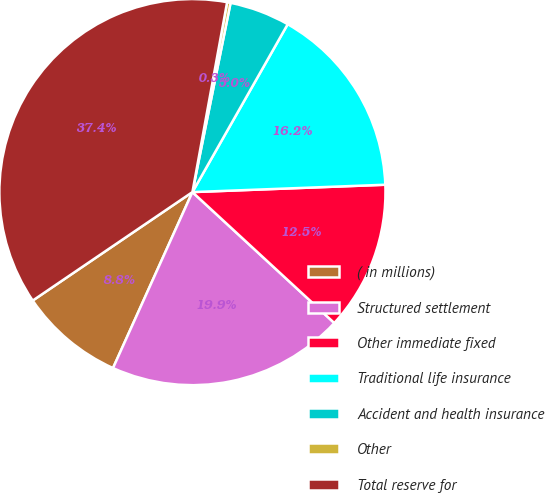<chart> <loc_0><loc_0><loc_500><loc_500><pie_chart><fcel>( in millions)<fcel>Structured settlement<fcel>Other immediate fixed<fcel>Traditional life insurance<fcel>Accident and health insurance<fcel>Other<fcel>Total reserve for<nl><fcel>8.76%<fcel>19.89%<fcel>12.47%<fcel>16.18%<fcel>5.05%<fcel>0.29%<fcel>37.38%<nl></chart> 